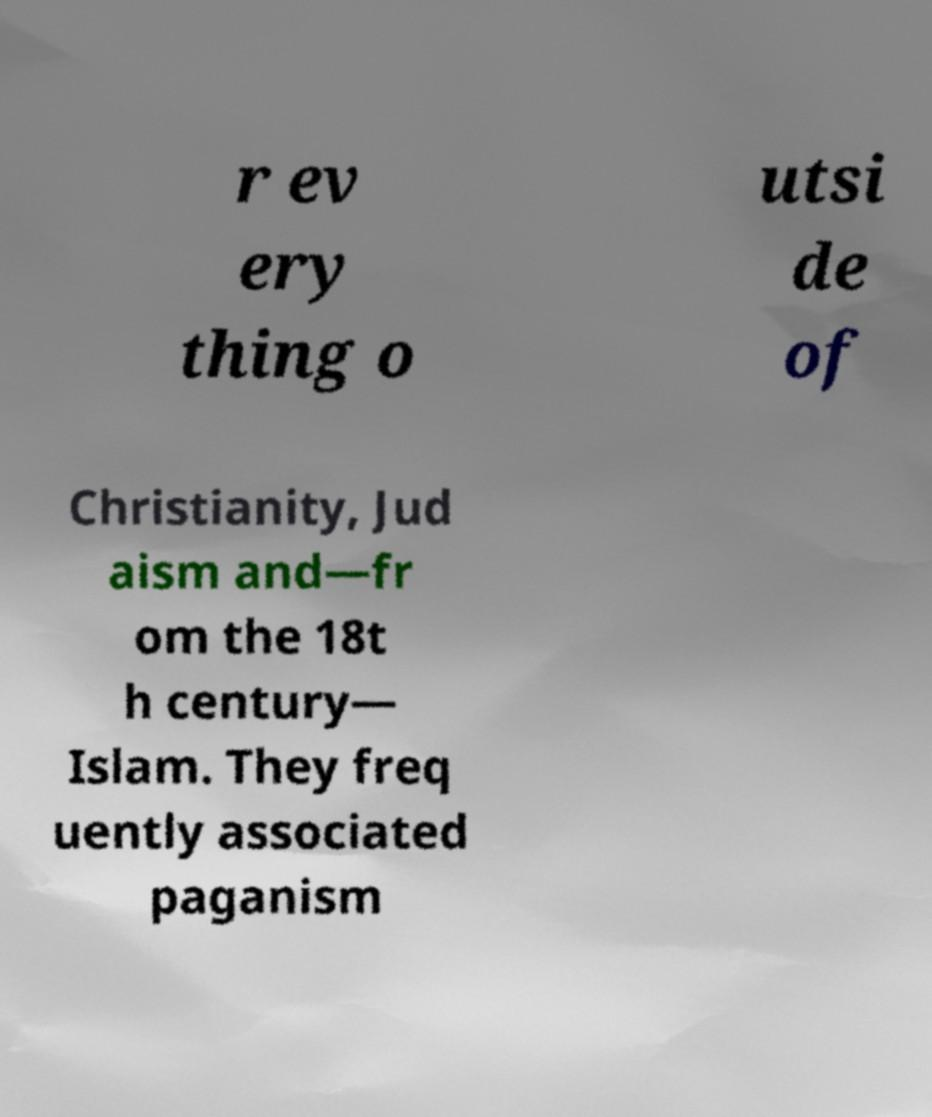Could you assist in decoding the text presented in this image and type it out clearly? r ev ery thing o utsi de of Christianity, Jud aism and—fr om the 18t h century— Islam. They freq uently associated paganism 